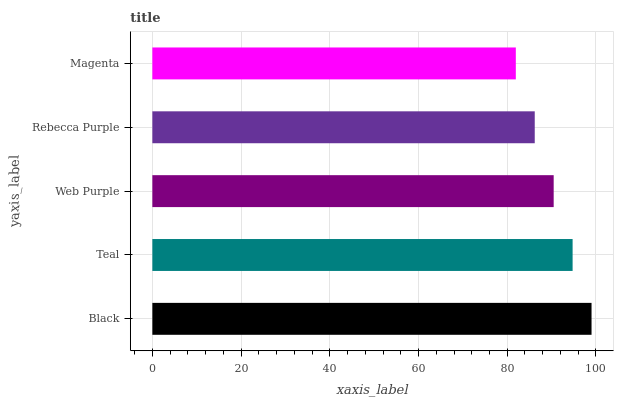Is Magenta the minimum?
Answer yes or no. Yes. Is Black the maximum?
Answer yes or no. Yes. Is Teal the minimum?
Answer yes or no. No. Is Teal the maximum?
Answer yes or no. No. Is Black greater than Teal?
Answer yes or no. Yes. Is Teal less than Black?
Answer yes or no. Yes. Is Teal greater than Black?
Answer yes or no. No. Is Black less than Teal?
Answer yes or no. No. Is Web Purple the high median?
Answer yes or no. Yes. Is Web Purple the low median?
Answer yes or no. Yes. Is Rebecca Purple the high median?
Answer yes or no. No. Is Rebecca Purple the low median?
Answer yes or no. No. 